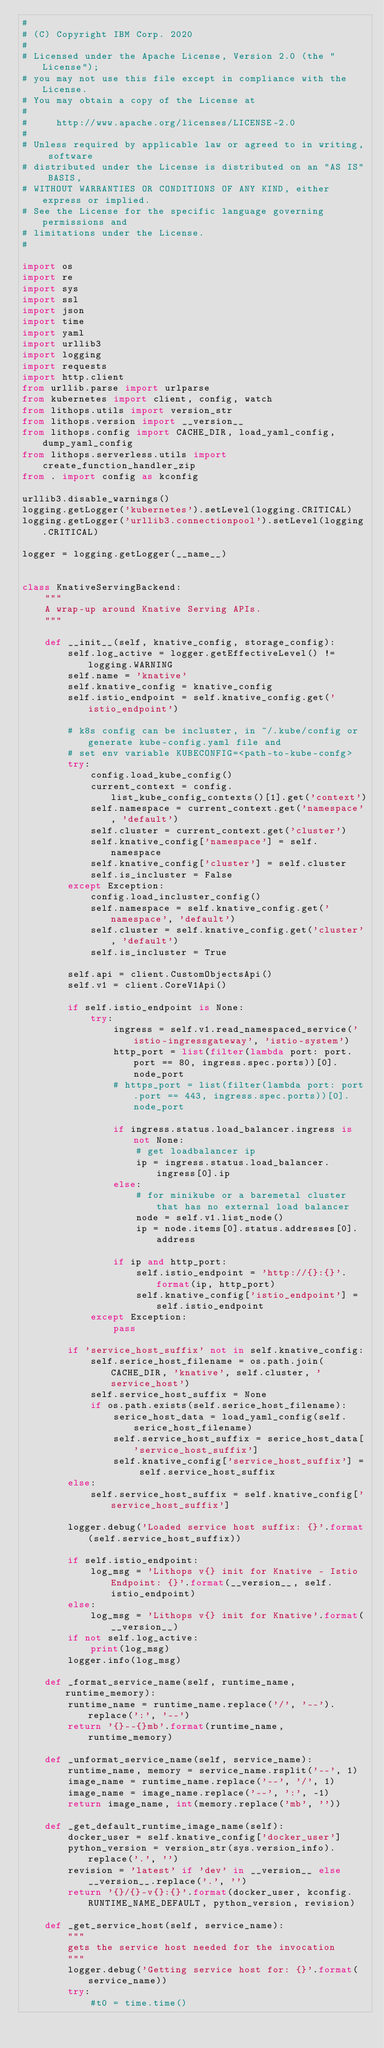Convert code to text. <code><loc_0><loc_0><loc_500><loc_500><_Python_>#
# (C) Copyright IBM Corp. 2020
#
# Licensed under the Apache License, Version 2.0 (the "License");
# you may not use this file except in compliance with the License.
# You may obtain a copy of the License at
#
#     http://www.apache.org/licenses/LICENSE-2.0
#
# Unless required by applicable law or agreed to in writing, software
# distributed under the License is distributed on an "AS IS" BASIS,
# WITHOUT WARRANTIES OR CONDITIONS OF ANY KIND, either express or implied.
# See the License for the specific language governing permissions and
# limitations under the License.
#

import os
import re
import sys
import ssl
import json
import time
import yaml
import urllib3
import logging
import requests
import http.client
from urllib.parse import urlparse
from kubernetes import client, config, watch
from lithops.utils import version_str
from lithops.version import __version__
from lithops.config import CACHE_DIR, load_yaml_config, dump_yaml_config
from lithops.serverless.utils import create_function_handler_zip
from . import config as kconfig

urllib3.disable_warnings()
logging.getLogger('kubernetes').setLevel(logging.CRITICAL)
logging.getLogger('urllib3.connectionpool').setLevel(logging.CRITICAL)

logger = logging.getLogger(__name__)


class KnativeServingBackend:
    """
    A wrap-up around Knative Serving APIs.
    """

    def __init__(self, knative_config, storage_config):
        self.log_active = logger.getEffectiveLevel() != logging.WARNING
        self.name = 'knative'
        self.knative_config = knative_config
        self.istio_endpoint = self.knative_config.get('istio_endpoint')

        # k8s config can be incluster, in ~/.kube/config or generate kube-config.yaml file and
        # set env variable KUBECONFIG=<path-to-kube-confg>
        try:
            config.load_kube_config()
            current_context = config.list_kube_config_contexts()[1].get('context')
            self.namespace = current_context.get('namespace', 'default')
            self.cluster = current_context.get('cluster')
            self.knative_config['namespace'] = self.namespace
            self.knative_config['cluster'] = self.cluster
            self.is_incluster = False
        except Exception:
            config.load_incluster_config()
            self.namespace = self.knative_config.get('namespace', 'default')
            self.cluster = self.knative_config.get('cluster', 'default')
            self.is_incluster = True

        self.api = client.CustomObjectsApi()
        self.v1 = client.CoreV1Api()

        if self.istio_endpoint is None:
            try:
                ingress = self.v1.read_namespaced_service('istio-ingressgateway', 'istio-system')
                http_port = list(filter(lambda port: port.port == 80, ingress.spec.ports))[0].node_port
                # https_port = list(filter(lambda port: port.port == 443, ingress.spec.ports))[0].node_port

                if ingress.status.load_balancer.ingress is not None:
                    # get loadbalancer ip
                    ip = ingress.status.load_balancer.ingress[0].ip
                else:
                    # for minikube or a baremetal cluster that has no external load balancer
                    node = self.v1.list_node()
                    ip = node.items[0].status.addresses[0].address

                if ip and http_port:
                    self.istio_endpoint = 'http://{}:{}'.format(ip, http_port)
                    self.knative_config['istio_endpoint'] = self.istio_endpoint
            except Exception:
                pass

        if 'service_host_suffix' not in self.knative_config:
            self.serice_host_filename = os.path.join(CACHE_DIR, 'knative', self.cluster, 'service_host')
            self.service_host_suffix = None
            if os.path.exists(self.serice_host_filename):
                serice_host_data = load_yaml_config(self.serice_host_filename)
                self.service_host_suffix = serice_host_data['service_host_suffix']
                self.knative_config['service_host_suffix'] = self.service_host_suffix
        else:
            self.service_host_suffix = self.knative_config['service_host_suffix']

        logger.debug('Loaded service host suffix: {}'.format(self.service_host_suffix))

        if self.istio_endpoint:
            log_msg = 'Lithops v{} init for Knative - Istio Endpoint: {}'.format(__version__, self.istio_endpoint)
        else:
            log_msg = 'Lithops v{} init for Knative'.format(__version__)
        if not self.log_active:
            print(log_msg)
        logger.info(log_msg)

    def _format_service_name(self, runtime_name, runtime_memory):
        runtime_name = runtime_name.replace('/', '--').replace(':', '--')
        return '{}--{}mb'.format(runtime_name, runtime_memory)

    def _unformat_service_name(self, service_name):
        runtime_name, memory = service_name.rsplit('--', 1)
        image_name = runtime_name.replace('--', '/', 1)
        image_name = image_name.replace('--', ':', -1)
        return image_name, int(memory.replace('mb', ''))

    def _get_default_runtime_image_name(self):
        docker_user = self.knative_config['docker_user']
        python_version = version_str(sys.version_info).replace('.', '')
        revision = 'latest' if 'dev' in __version__ else __version__.replace('.', '')
        return '{}/{}-v{}:{}'.format(docker_user, kconfig.RUNTIME_NAME_DEFAULT, python_version, revision)

    def _get_service_host(self, service_name):
        """
        gets the service host needed for the invocation
        """
        logger.debug('Getting service host for: {}'.format(service_name))
        try:
            #t0 = time.time()</code> 